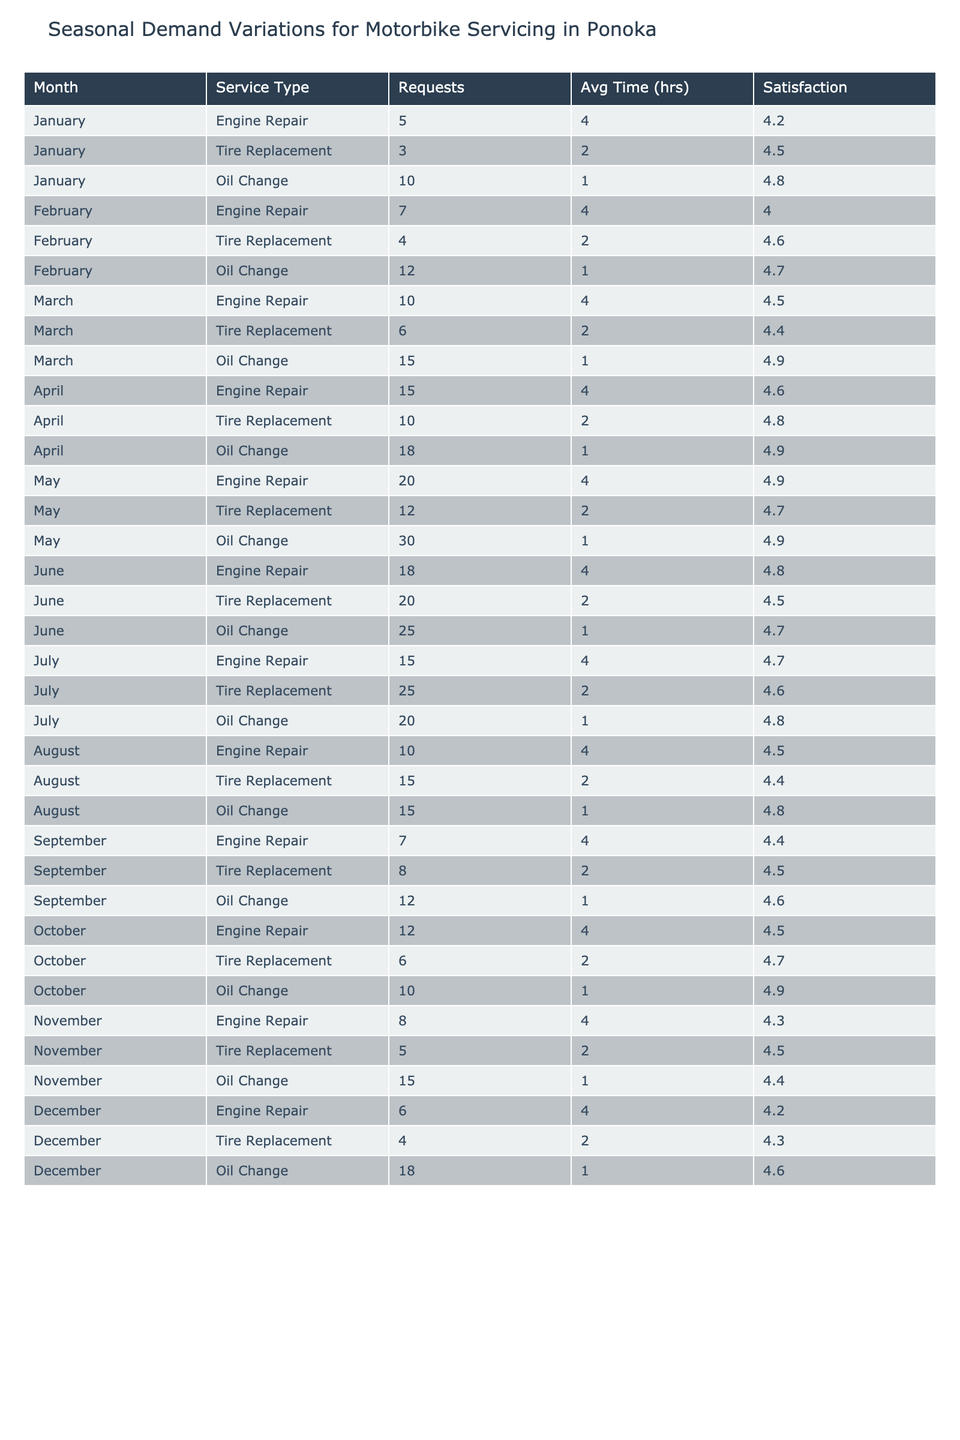What is the service type with the highest number of servicing requests in May? In May, the tire replacement requests totaled 12, while engine repair had 20 and oil change had 30. Therefore, oil change is the service type with the highest requests.
Answer: Oil Change How many engine repairs were requested in December? Looking at the table, for December, engine repairs have a total of 6 requests.
Answer: 6 What is the average service time for tire replacements in June? For June, the average service time for tire replacements is 2 hours, as listed directly in the table.
Answer: 2 hours True or False: The customer satisfaction rating for oil changes is above 4.5 for all months. By checking each month’s oil change satisfaction rating, I find January at 4.8, February at 4.7, March at 4.9, April at 4.9, May at 4.9, June at 4.7, July at 4.8, August at 4.8, September at 4.6, October at 4.9, November at 4.4, and December at 4.6. November is below 4.5, so the statement is false.
Answer: False What was the total number of oil change requests throughout the year? Summing up the oil change requests for each month: 10 (Jan) + 12 (Feb) + 15 (Mar) + 18 (Apr) + 30 (May) + 25 (Jun) + 20 (Jul) + 15 (Aug) + 12 (Sep) + 10 (Oct) + 15 (Nov) + 18 (Dec) =  5 + 12 + 18 + 30 + 25 + 20 + 15 + 12 + 10 + 15 + 18 =  200 total requests.
Answer: 200 Which month had the highest customer satisfaction rating for engine repairs? Reviewing the customer satisfaction ratings for engine repairs: January 4.2, February 4.0, March 4.5, April 4.6, May 4.9, June 4.8, July 4.7, August 4.5, September 4.4, October 4.5, November 4.3, and December 4.2. The highest rating is from May at 4.9.
Answer: May What is the difference between the number of tire replacement requests in July and June? Tire replacement requests in July total 25, and in June, they total 20. Subtracting these gives 25 - 20 = 5 more requests in July than in June.
Answer: 5 During which month were the average service times for all service types the longest? By examining the average service times across all months: January, February, March through December all have 1 hour for oil changes and 4 hours for repairs. The average service times for tire replacements and oil changes show most months have a service time of just 2 hours. January, February, and March all rate engine repair at 4 hours. Thus, all of these months rate the longest average service time of 4 hours.
Answer: January, February, March What was the overall trend for customer satisfaction for oil changes from January to December? Reviewing the ratings shows a decline: 4.8 (Jan), 4.7 (Feb), 4.9 (Mar), 4.9 (Apr), 4.9 (May), 4.7 (Jun), 4.8 (Jul), 4.8 (Aug), 4.6 (Sep), 4.9 (Oct), 4.4 (Nov), 4.6 (Dec). Although there were fluctuations, the trend shows no significant long-term decline.
Answer: Fluctuating with no significant decline What is the service type that had the lowest average satisfaction rating? Calculating the average satisfaction ratings for each service type: Engine repair averages around 4.47 across all months, tire replacements average at 4.5, and oil changes average approximately 4.65. Engine repair has the lowest average satisfaction rating of 4.47.
Answer: Engine Repair Which month had the maximum total number of servicing requests and how many were there? Tally looks as follows: May totals 62 (20 engine, 12 tire, 30 oil), June 63 (18 engine, 20 tire, 25 oil), and other months yield lower totals. June has the highest at 63 requests.
Answer: June, 63 requests 